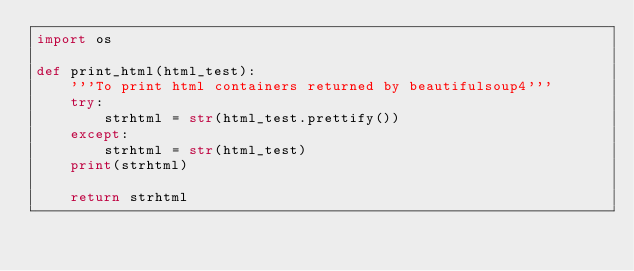Convert code to text. <code><loc_0><loc_0><loc_500><loc_500><_Python_>import os

def print_html(html_test):
    '''To print html containers returned by beautifulsoup4'''
    try:
        strhtml = str(html_test.prettify())
    except:
        strhtml = str(html_test)
    print(strhtml)

    return strhtml</code> 